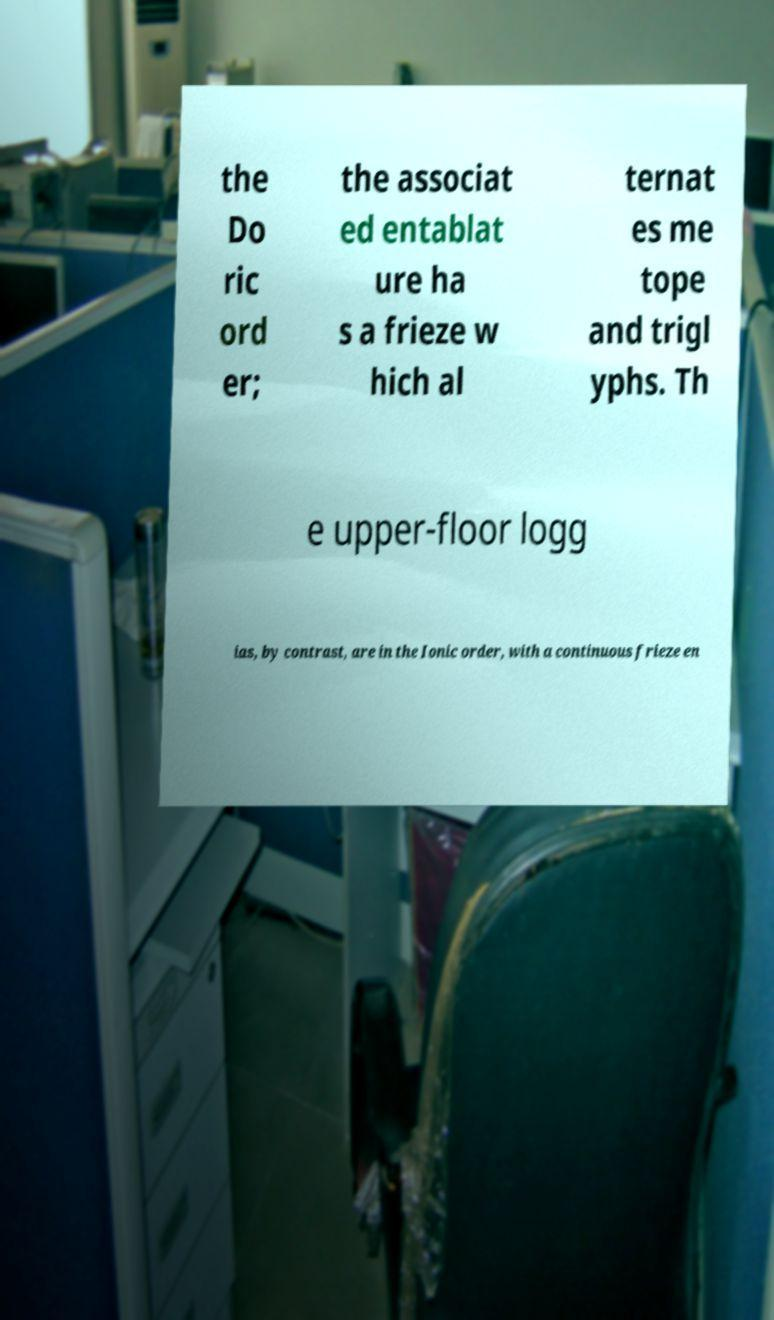Could you assist in decoding the text presented in this image and type it out clearly? the Do ric ord er; the associat ed entablat ure ha s a frieze w hich al ternat es me tope and trigl yphs. Th e upper-floor logg ias, by contrast, are in the Ionic order, with a continuous frieze en 